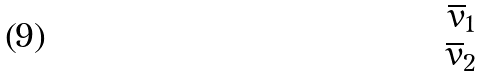Convert formula to latex. <formula><loc_0><loc_0><loc_500><loc_500>\begin{matrix} \overline { v } _ { 1 } \\ \overline { v } _ { 2 } \end{matrix}</formula> 